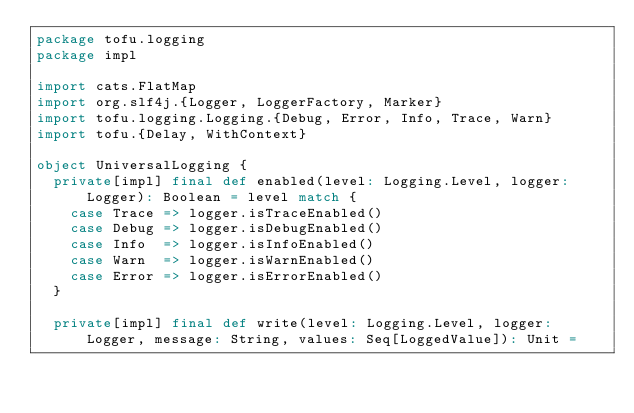<code> <loc_0><loc_0><loc_500><loc_500><_Scala_>package tofu.logging
package impl

import cats.FlatMap
import org.slf4j.{Logger, LoggerFactory, Marker}
import tofu.logging.Logging.{Debug, Error, Info, Trace, Warn}
import tofu.{Delay, WithContext}

object UniversalLogging {
  private[impl] final def enabled(level: Logging.Level, logger: Logger): Boolean = level match {
    case Trace => logger.isTraceEnabled()
    case Debug => logger.isDebugEnabled()
    case Info  => logger.isInfoEnabled()
    case Warn  => logger.isWarnEnabled()
    case Error => logger.isErrorEnabled()
  }

  private[impl] final def write(level: Logging.Level, logger: Logger, message: String, values: Seq[LoggedValue]): Unit =</code> 